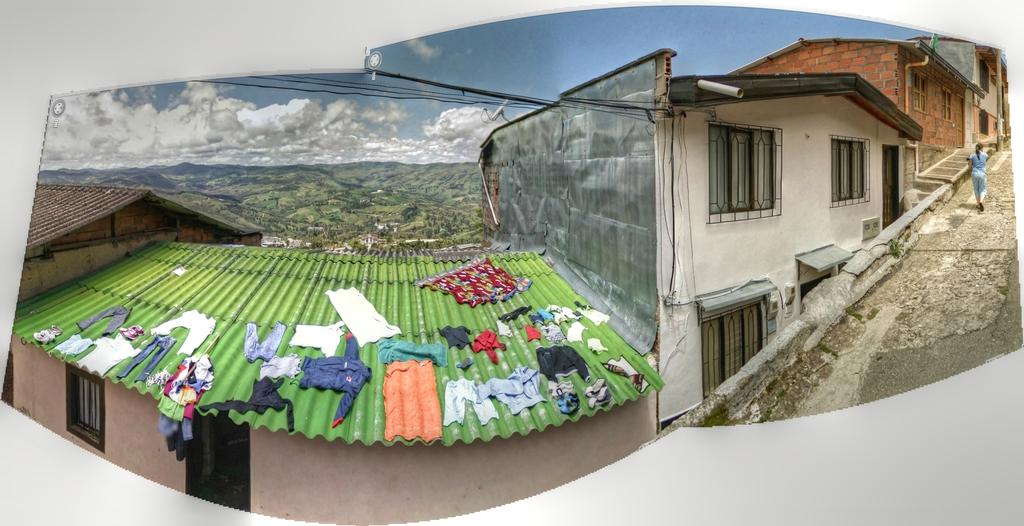What is the nature of the image? The image appears to be edited. What is the person in the image doing? There is a person walking on the road in the image. What type of structures can be seen in the image? There are buildings in the image. What can be seen on the person in the image? Clothes are visible in the image. What type of infrastructure is present in the image? Cables are present in the image. What type of vegetation is present in the image? Trees are present in the image. What type of geographical feature is visible in the image? Hills are visible in the image. What is visible in the background of the image? The sky is visible in the background of the image. Where is the monkey sitting in the image? There is no monkey present in the image. What type of base is supporting the buildings in the image? The buildings in the image are not shown to be supported by any specific base. 